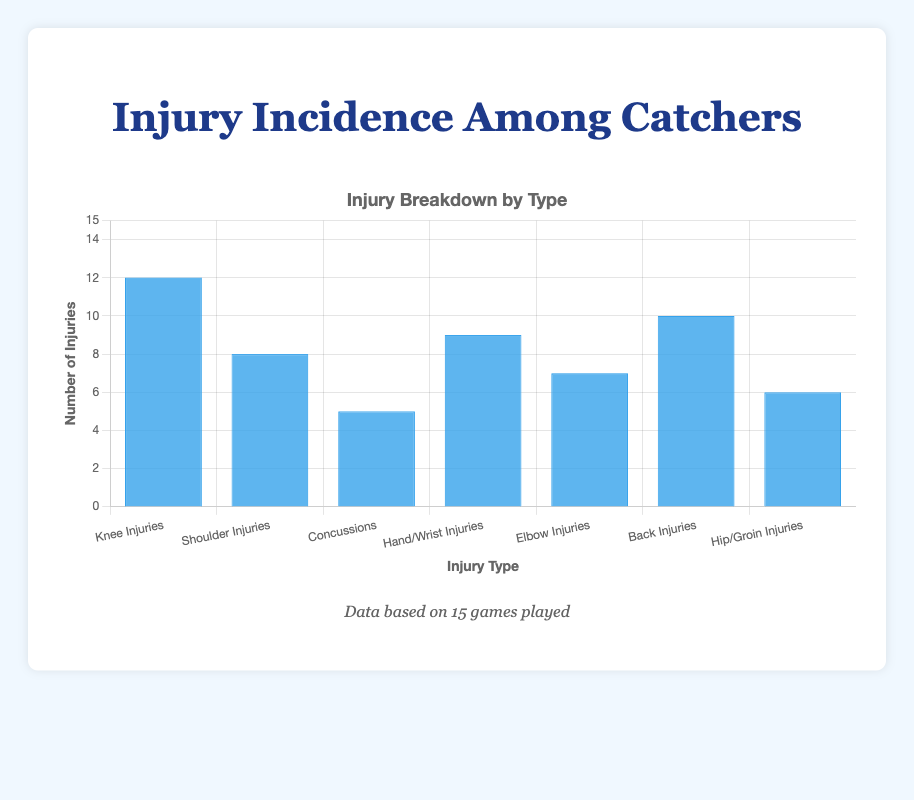What's the most common type of injury among catchers? The figure shows different types of injuries with blue bars indicating the number of injuries. The bar for "Knee Injuries" is the highest.
Answer: Knee Injuries Which injury type has the least number of injuries? By comparing the height of the bars, "Concussions" has the shortest bar, indicating the fewest injuries.
Answer: Concussions How many more knee injuries are there compared to hip/groin injuries? The number of knee injuries is 12 and hip/groin injuries is 6. Therefore, the difference is 12 - 6 = 6.
Answer: 6 What is the total number of injuries across all types? Sum up the number of injuries for each type: 12 (Knee) + 8 (Shoulder) + 5 (Concussions) + 9 (Hand/Wrist) + 7 (Elbow) + 10 (Back) + 6 (Hip/Groin) = 57.
Answer: 57 Are hand/wrist injuries more or less common than elbow injuries? By comparing the heights of the bars, hand/wrist injuries (9) are more common than elbow injuries (7).
Answer: More common What is the average number of injuries per type? The total number of injuries is 57 and there are 7 types. So, the average is 57 / 7 = 8.14.
Answer: 8.14 Which two injury types are closest in frequency? By examining the bar heights, shoulder injuries (8) and elbow injuries (7) are closest in number.
Answer: Shoulder Injuries and Elbow Injuries What's the combined number of knee and back injuries? Sum the number of knee injuries (12) and back injuries (10): 12 + 10 = 22.
Answer: 22 Is the number of shoulder injuries greater than or equal to the number of hip/groin injuries? Comparing the bars, shoulder injuries (8) are greater than hip/groin injuries (6).
Answer: Greater 